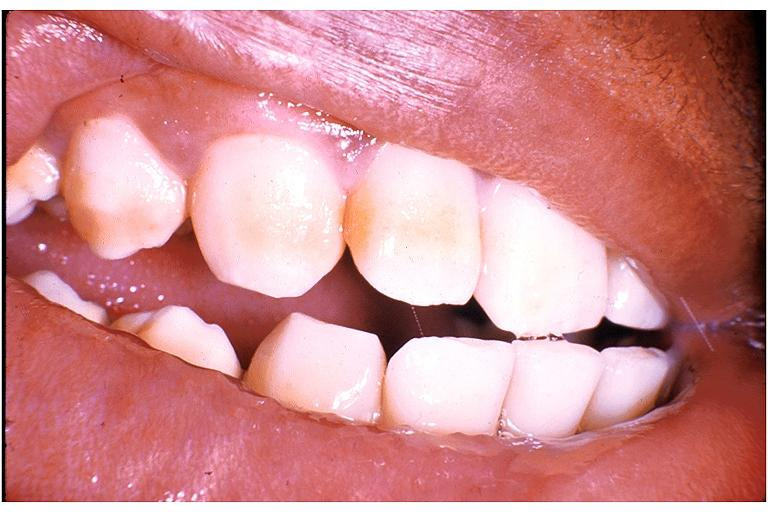what does this image show?
Answer the question using a single word or phrase. Fluorosis 